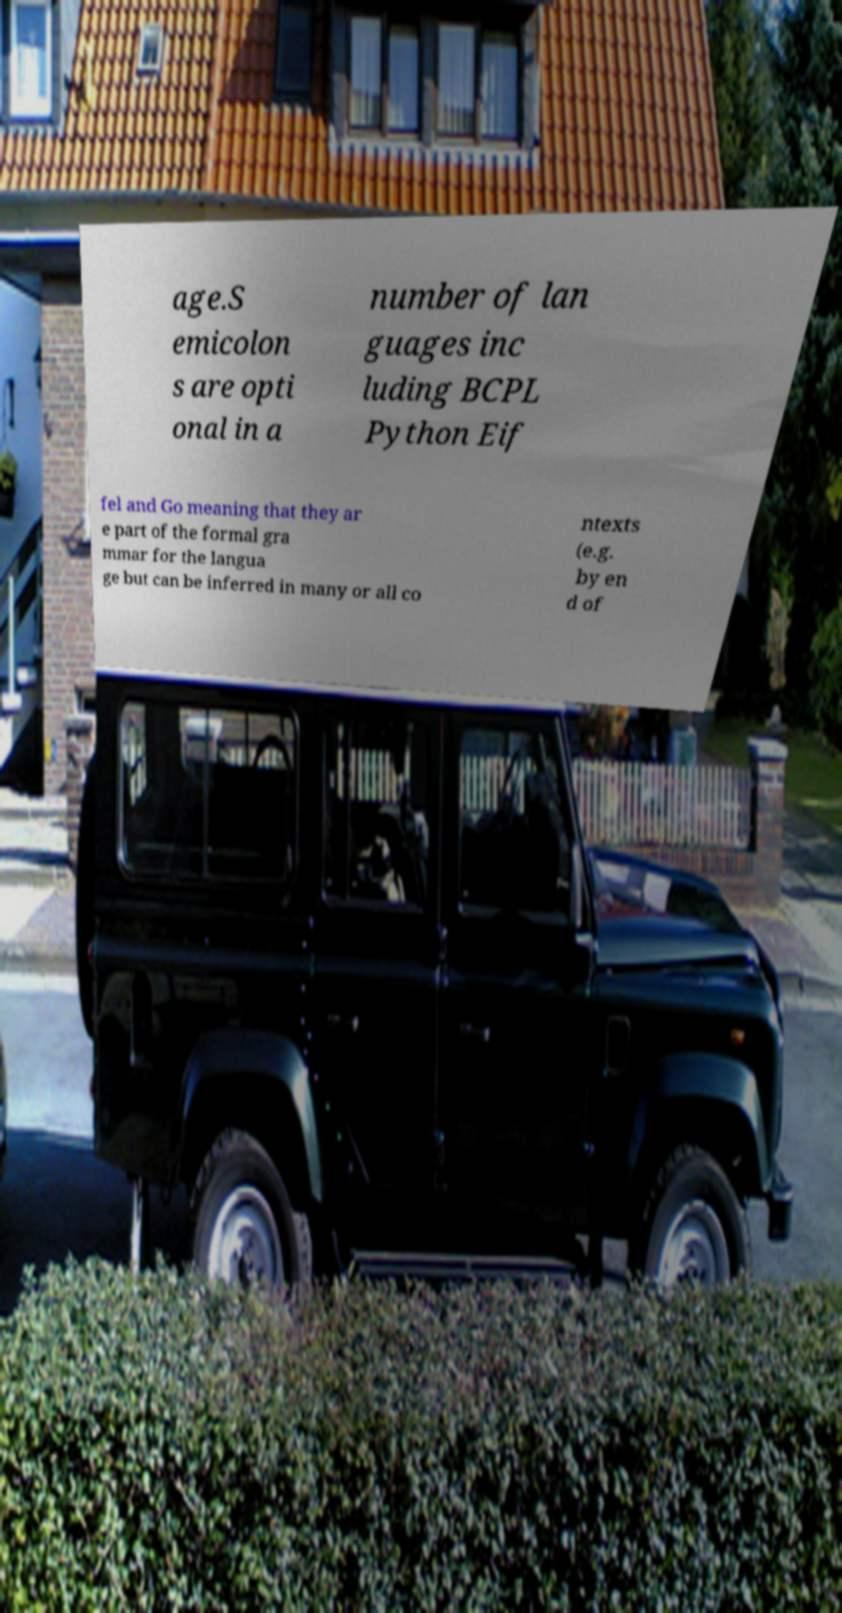Can you read and provide the text displayed in the image?This photo seems to have some interesting text. Can you extract and type it out for me? age.S emicolon s are opti onal in a number of lan guages inc luding BCPL Python Eif fel and Go meaning that they ar e part of the formal gra mmar for the langua ge but can be inferred in many or all co ntexts (e.g. by en d of 